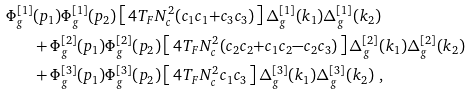Convert formula to latex. <formula><loc_0><loc_0><loc_500><loc_500>\Phi _ { g } ^ { [ 1 ] } & ( p _ { 1 } ) \Phi _ { g } ^ { [ 1 ] } ( p _ { 2 } ) \left [ \, 4 T _ { F } N _ { c } ^ { 2 } ( c _ { 1 } c _ { 1 } { + } c _ { 3 } c _ { 3 } ) \, \right ] \Delta _ { g } ^ { [ 1 ] } ( k _ { 1 } ) \Delta _ { g } ^ { [ 1 ] } ( k _ { 2 } ) \\ & + \Phi _ { g } ^ { [ 2 ] } ( p _ { 1 } ) \Phi _ { g } ^ { [ 2 ] } ( p _ { 2 } ) \left [ \, 4 T _ { F } N _ { c } ^ { 2 } ( c _ { 2 } c _ { 2 } { + } c _ { 1 } c _ { 2 } { - } c _ { 2 } c _ { 3 } ) \, \right ] \Delta _ { g } ^ { [ 2 ] } ( k _ { 1 } ) \Delta _ { g } ^ { [ 2 ] } ( k _ { 2 } ) \\ & + \Phi _ { g } ^ { [ 3 ] } ( p _ { 1 } ) \Phi _ { g } ^ { [ 3 ] } ( p _ { 2 } ) \left [ \, 4 T _ { F } N _ { c } ^ { 2 } c _ { 1 } c _ { 3 } \, \right ] \Delta _ { g } ^ { [ 3 ] } ( k _ { 1 } ) \Delta _ { g } ^ { [ 3 ] } ( k _ { 2 } ) \ ,</formula> 